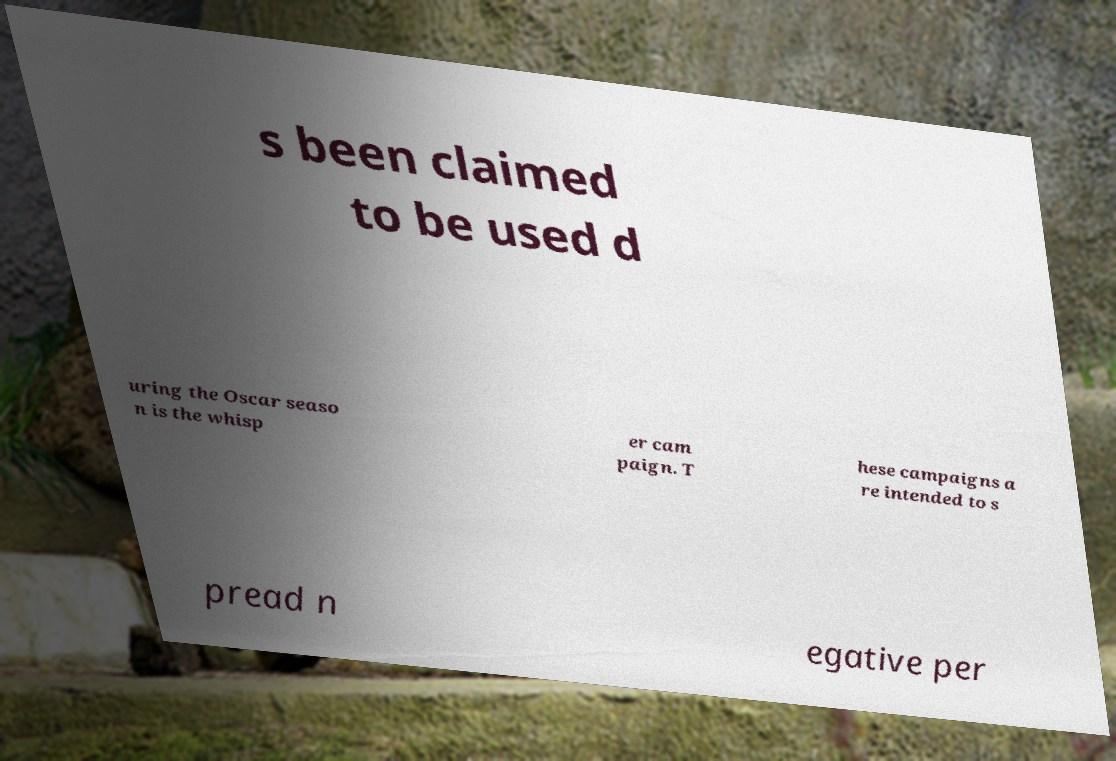For documentation purposes, I need the text within this image transcribed. Could you provide that? s been claimed to be used d uring the Oscar seaso n is the whisp er cam paign. T hese campaigns a re intended to s pread n egative per 